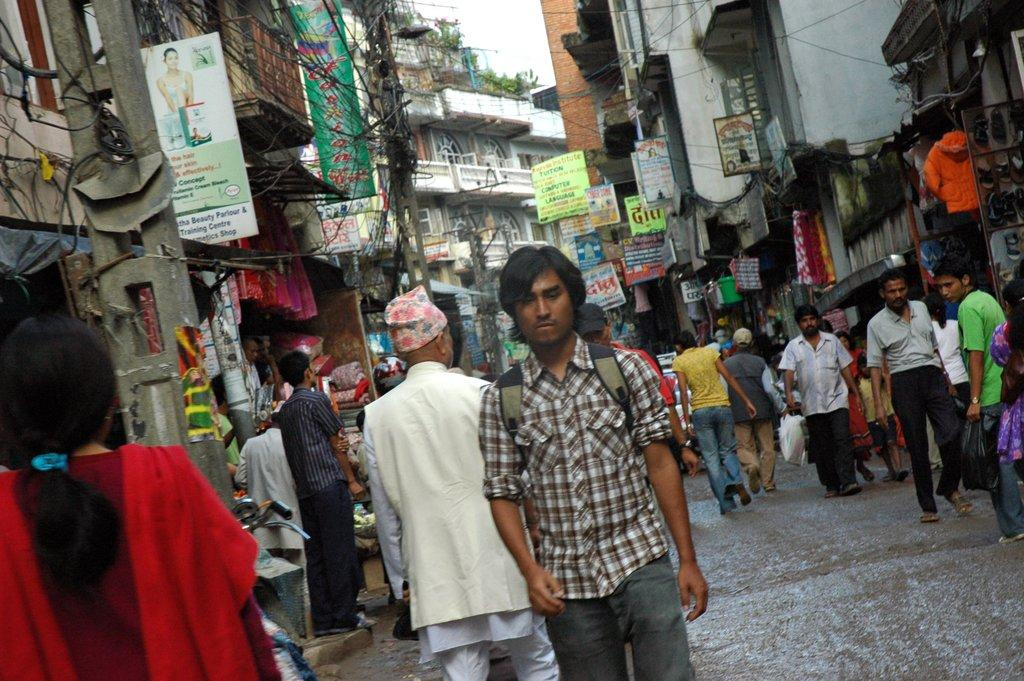What is happening at the bottom of the image? There are people walking and standing at the bottom of the image. What objects can be seen in the image that are vertical in nature? There are poles in the image. What type of signage is present in the image? There are banners in the image. What type of structures are visible in the image? There are buildings in the image. What type of vegetation is present in the image? There are plants in the image. How much money is being exchanged between the people in the image? There is no indication of money being exchanged in the image; it only shows people walking and standing, poles, banners, buildings, and plants. 